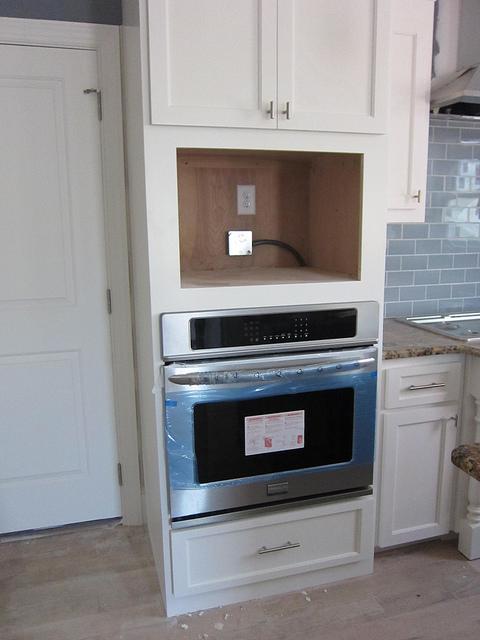What color are the cabinets?
Quick response, please. White. What kind of ovens are those?
Be succinct. Convection. How many empty shelves are pictured?
Give a very brief answer. 1. What brand is the stove?
Keep it brief. Kenmore. What is missing above the stove?
Be succinct. Microwave. In what setting would you typically find this type of efficiency?
Write a very short answer. Kitchen. What appliance can be seen?
Be succinct. Oven. How many handles can you spot?
Answer briefly. 6. 